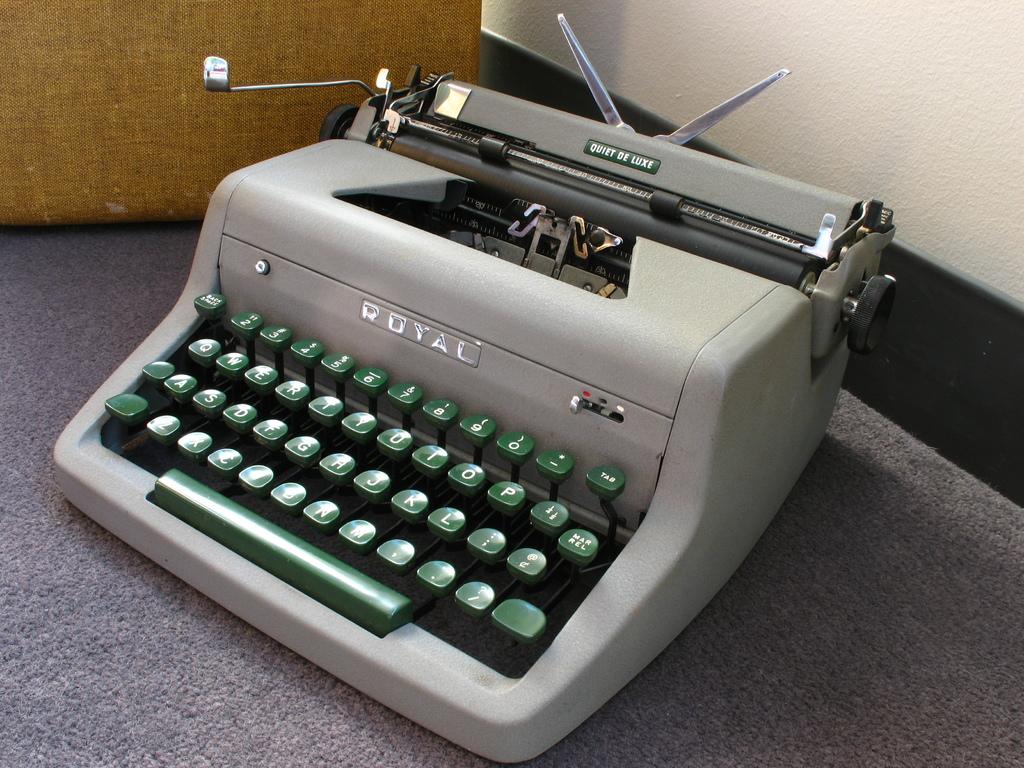What brand of type writer is this?
Offer a terse response. Royal. What is written on the arm of the typewritter?
Your response must be concise. Quiet de luxe. 